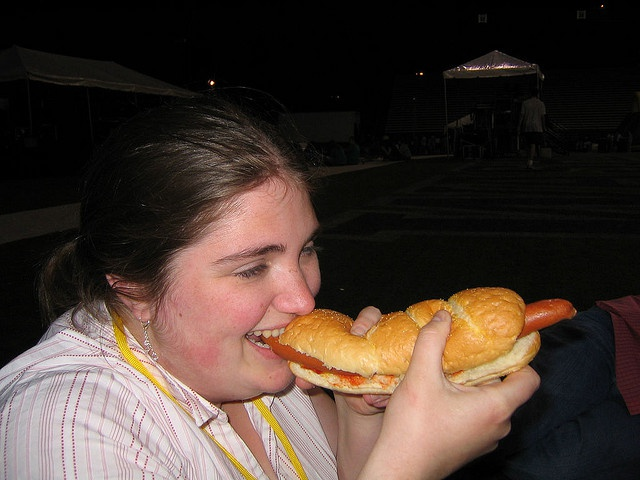Describe the objects in this image and their specific colors. I can see people in black, lightpink, gray, and lightgray tones, hot dog in black, orange, red, and tan tones, people in black tones, and people in black tones in this image. 